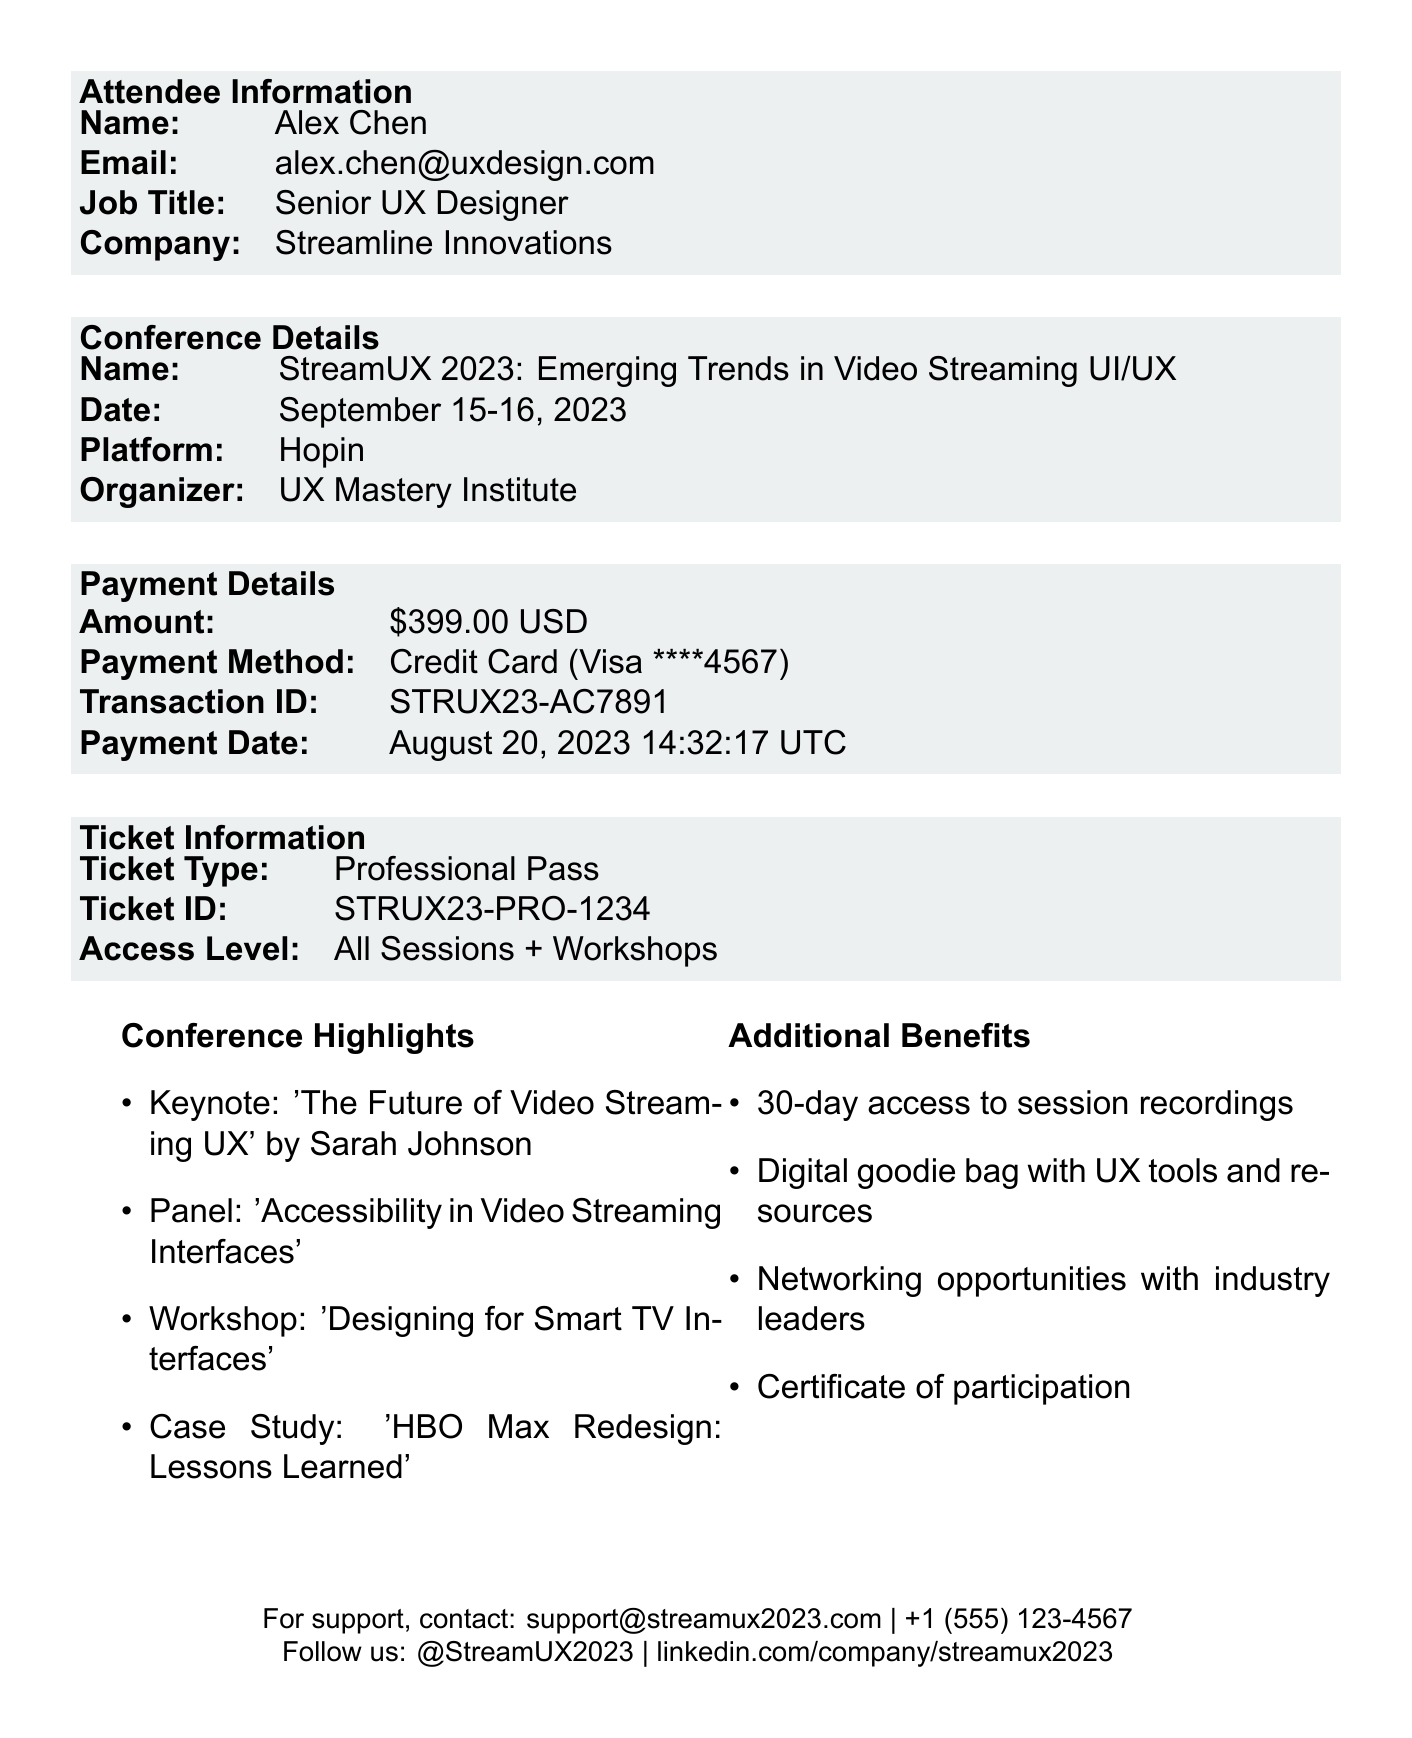What is the amount paid for the conference? The amount paid is explicitly stated in the payment details section of the document.
Answer: $399.00 Who is the organizer of the conference? The organizer's name is mentioned in the conference details section.
Answer: UX Mastery Institute What is the date of the conference? The date is provided in the conference details section as September 15-16, 2023.
Answer: September 15-16, 2023 What is the access level for the ticket type purchased? The access level is specified under the ticket information section.
Answer: All Sessions + Workshops What is the cancellation policy refund percentage? The refund percentage is detailed in the cancellation policy section of the document.
Answer: 80 What is the ticket type of the registration? The ticket type is clearly mentioned in the ticket information section.
Answer: Professional Pass Who is the keynote speaker for the conference? The keynote speaker's name is part of the conference highlights.
Answer: Sarah Johnson What are the minimum internet speed requirements? The required internet speed is outlined in the technical requirements section of the document.
Answer: Minimum 5 Mbps download, 2 Mbps upload What is the contact email for event support? The contact email for support is specified towards the end of the document.
Answer: support@streamux2023.com 